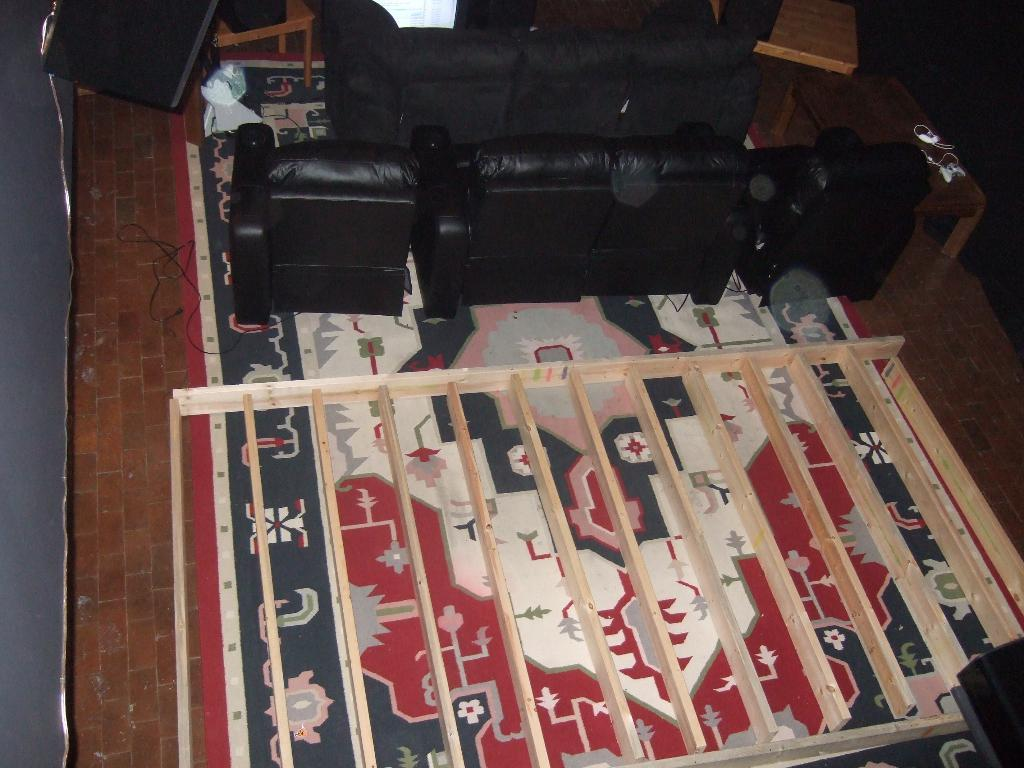What type of furniture is present in the image? There are sofas in the image. What is located in front of the sofas? There is a wooden object in front of the sofas. Where is the table positioned in relation to the sofas? There is a table on the right side of the sofas. How many objects are on the table? There are two objects on the table. What country is depicted on the flag hanging from the ceiling in the image? There is no flag hanging from the ceiling in the image. How many balls are visible on the table in the image? There are no balls present on the table in the image. 